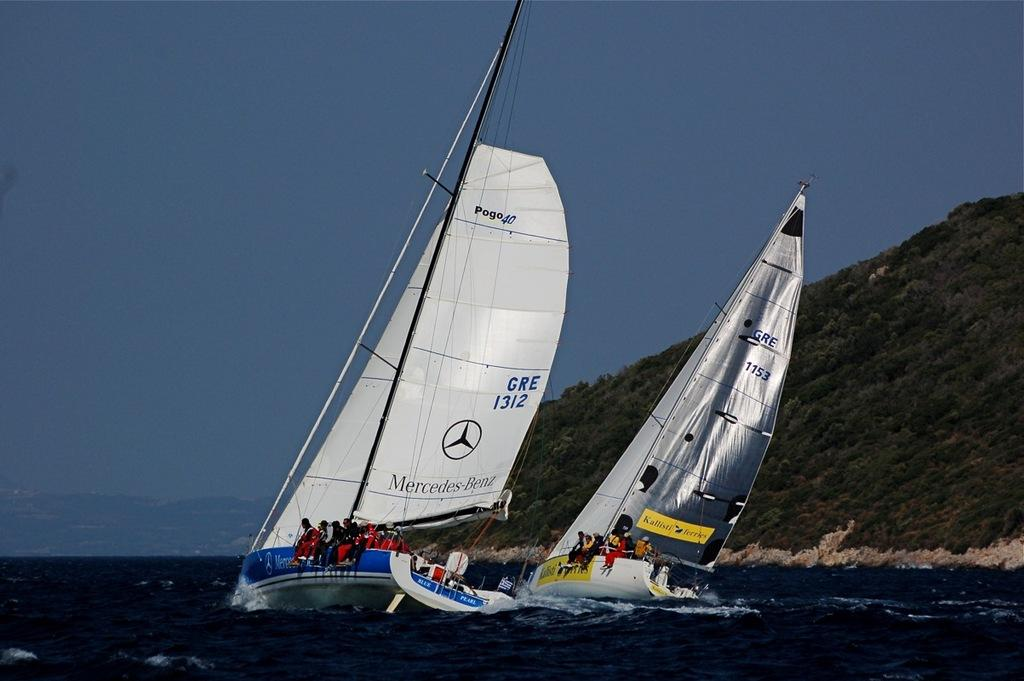<image>
Describe the image concisely. Ships with a white sail that says Mercedes Benz on it. 